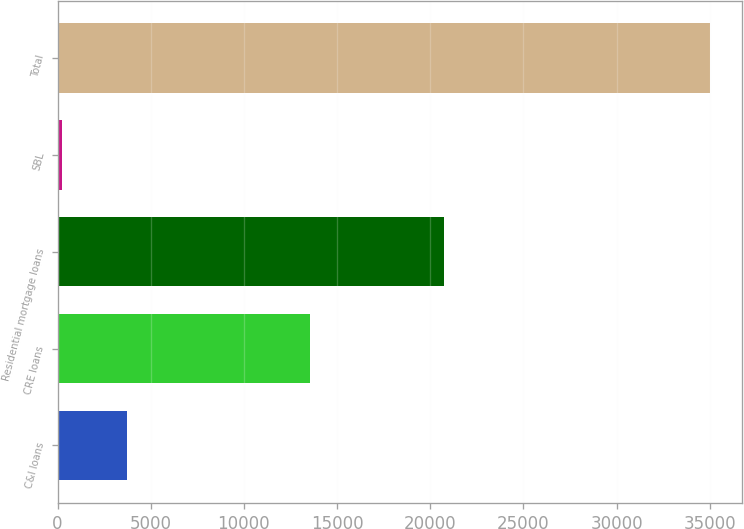Convert chart to OTSL. <chart><loc_0><loc_0><loc_500><loc_500><bar_chart><fcel>C&I loans<fcel>CRE loans<fcel>Residential mortgage loans<fcel>SBL<fcel>Total<nl><fcel>3720.9<fcel>13534<fcel>20757<fcel>246<fcel>34995<nl></chart> 